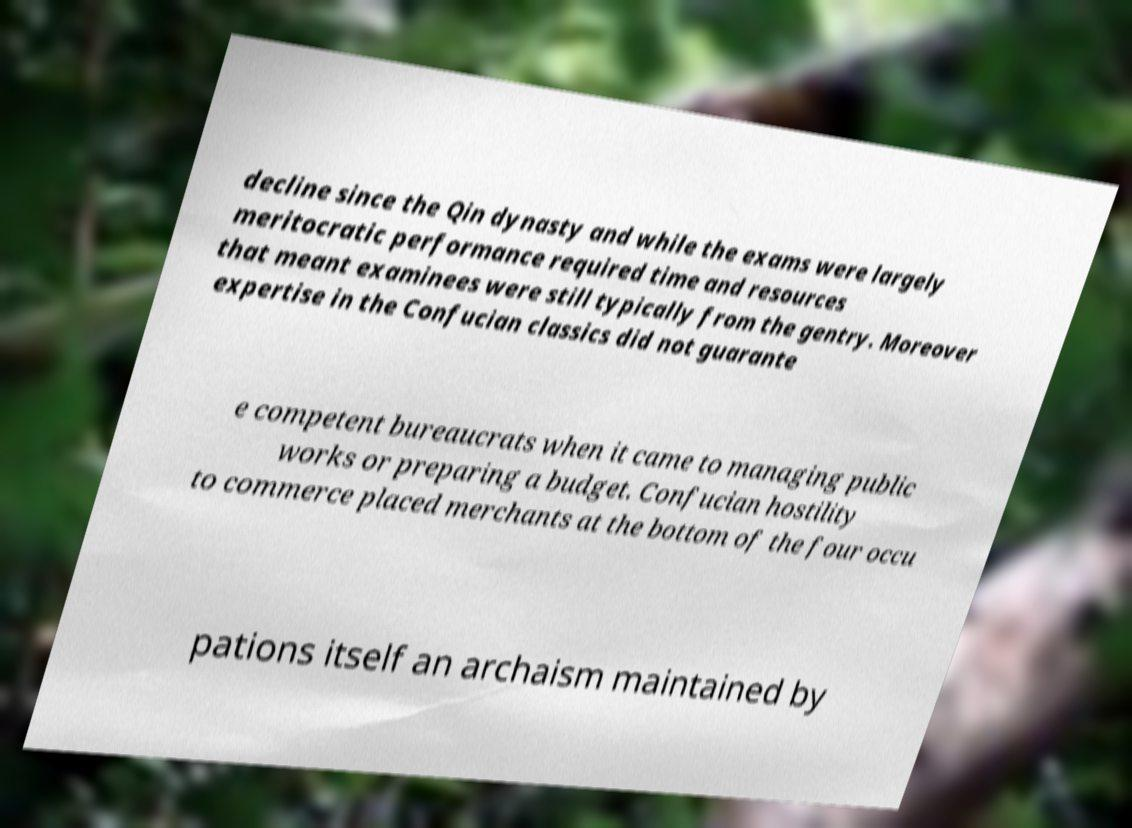Please read and relay the text visible in this image. What does it say? decline since the Qin dynasty and while the exams were largely meritocratic performance required time and resources that meant examinees were still typically from the gentry. Moreover expertise in the Confucian classics did not guarante e competent bureaucrats when it came to managing public works or preparing a budget. Confucian hostility to commerce placed merchants at the bottom of the four occu pations itself an archaism maintained by 